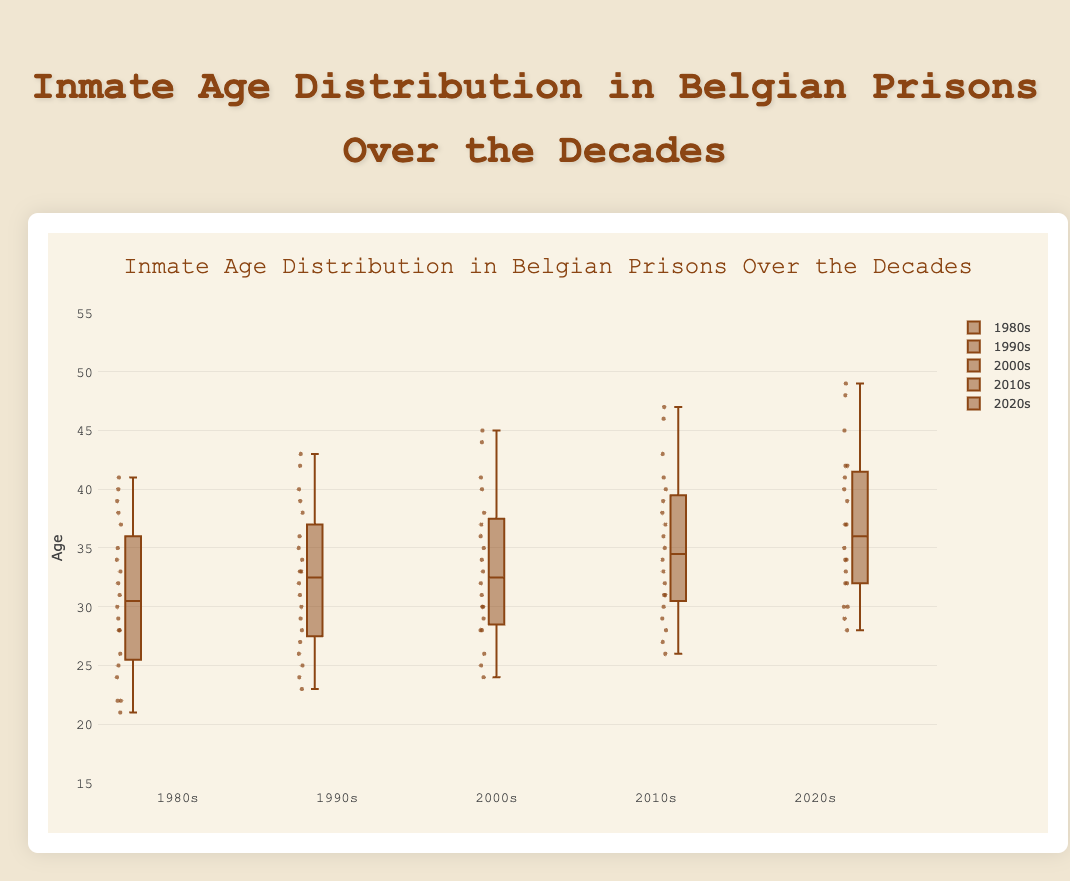Which decade has the highest median age of inmates? Look at the middle line in each box plot which represents the median. The 2020s have the highest middle line.
Answer: 2020s Which decade had the greatest range of inmate ages? The range can be observed by looking at the whiskers (edges of the plot). The 2010s and 2020s both have the highest maximum value of 49 but 2010s start from a lower minimum of 26 compared to 28 of 2020s.
Answer: 2010s Which decade's box plot has the highest number of outliers? Outliers are the points that fall outside the whiskers. Count the number of points outside the main box for each decade.
Answer: 1980s What is the median age of inmates in the 1990s? The median age is the value at the middle line of the box plot. Look for the middle line in the box plot of the 1990s.
Answer: 33 Is the median age in the 2000s greater than in the 1980s? Compare the middle lines of the 2000s and 1980s box plots. The middle line of the 2000s is higher than that of the 1980s.
Answer: Yes Compare the interquartile ranges (IQR) of the 1980s and 2010s. Which is larger? The IQR is the range between the first quartile (bottom line of the box) and the third quartile (top line of the box). Compare the height of the boxes.
Answer: 2010s What decade has the least spread in inmate ages? The spread is seen in the length of the whiskers; the shortest whiskers indicate the least spread. The 1990s have the shortest whiskers.
Answer: 1990s How many decades show a maximum age of 50 or more? Check the whisker end points for each decade. None reach 50 or higher, but the 2010s and 2020s reach 49.
Answer: 0 Does the median inmate age in Belgian prisons tend to increase over the decades? Observe the trend of median lines from 1980s to 2020s. The median lines generally move higher in each subsequent decade.
Answer: Yes 